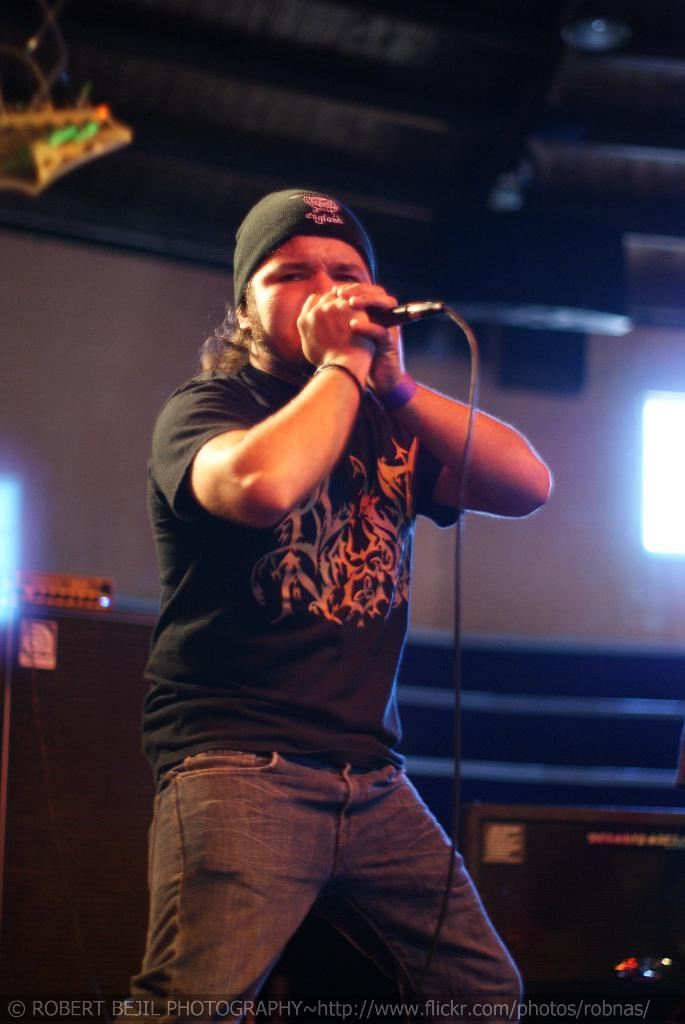Who or what is the main subject in the image? There is a person in the image. What is the person doing in the image? The person is standing and holding a mic. Can you describe the person's attire in the image? The person is wearing a cap. How does the person increase the volume of the mic in the image? There is no indication in the image that the person is adjusting the volume of the mic. What type of snack is the person eating in the image? There is no snack, such as popcorn, present in the image. 